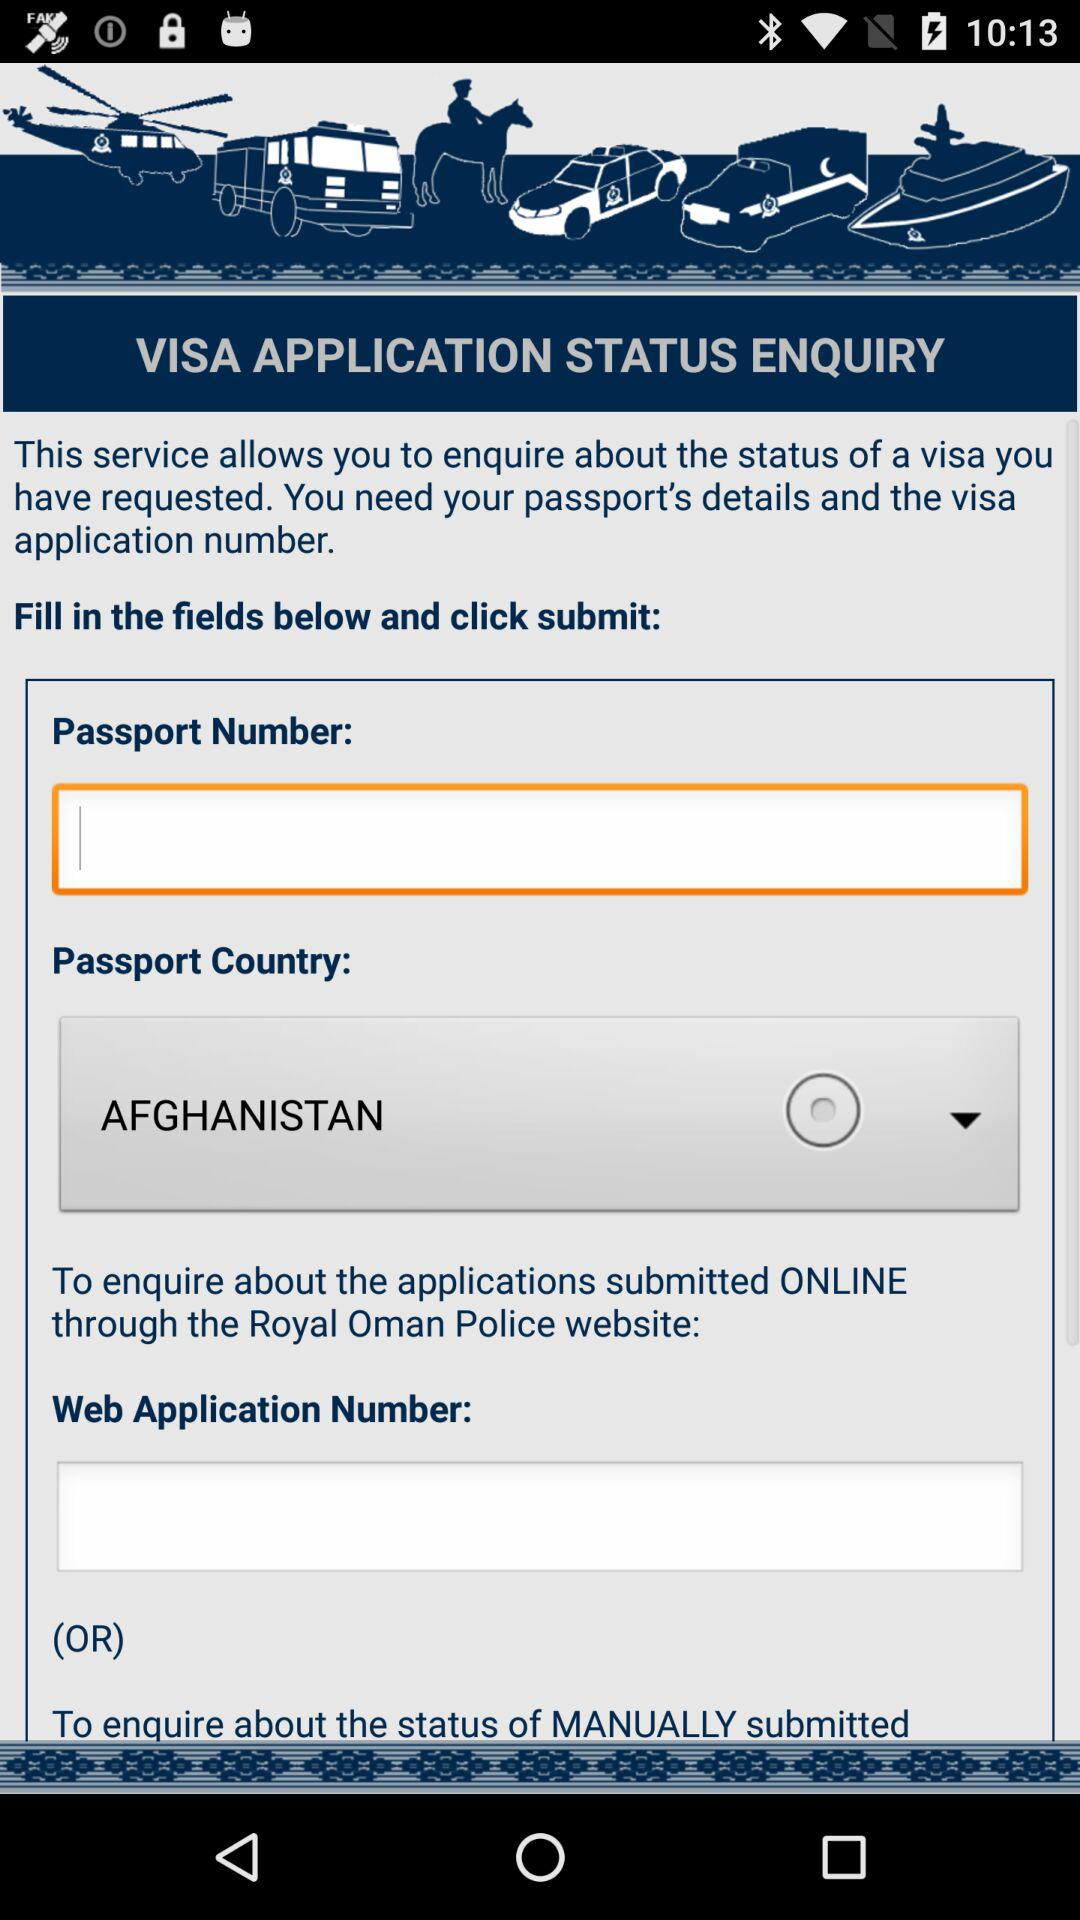How many text inputs are in the form?
Answer the question using a single word or phrase. 2 